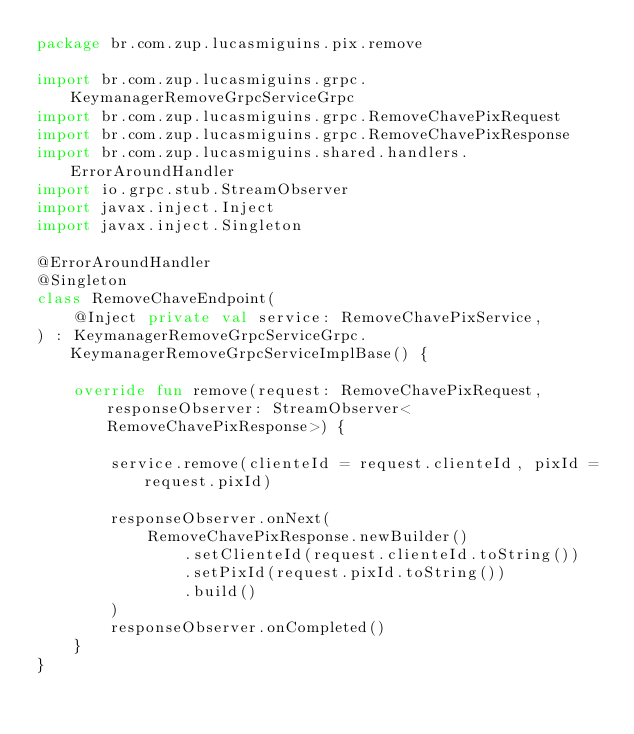Convert code to text. <code><loc_0><loc_0><loc_500><loc_500><_Kotlin_>package br.com.zup.lucasmiguins.pix.remove

import br.com.zup.lucasmiguins.grpc.KeymanagerRemoveGrpcServiceGrpc
import br.com.zup.lucasmiguins.grpc.RemoveChavePixRequest
import br.com.zup.lucasmiguins.grpc.RemoveChavePixResponse
import br.com.zup.lucasmiguins.shared.handlers.ErrorAroundHandler
import io.grpc.stub.StreamObserver
import javax.inject.Inject
import javax.inject.Singleton

@ErrorAroundHandler
@Singleton
class RemoveChaveEndpoint(
    @Inject private val service: RemoveChavePixService,
) : KeymanagerRemoveGrpcServiceGrpc.KeymanagerRemoveGrpcServiceImplBase() {

    override fun remove(request: RemoveChavePixRequest, responseObserver: StreamObserver<RemoveChavePixResponse>) {

        service.remove(clienteId = request.clienteId, pixId = request.pixId)

        responseObserver.onNext(
            RemoveChavePixResponse.newBuilder()
                .setClienteId(request.clienteId.toString())
                .setPixId(request.pixId.toString())
                .build()
        )
        responseObserver.onCompleted()
    }
}
</code> 